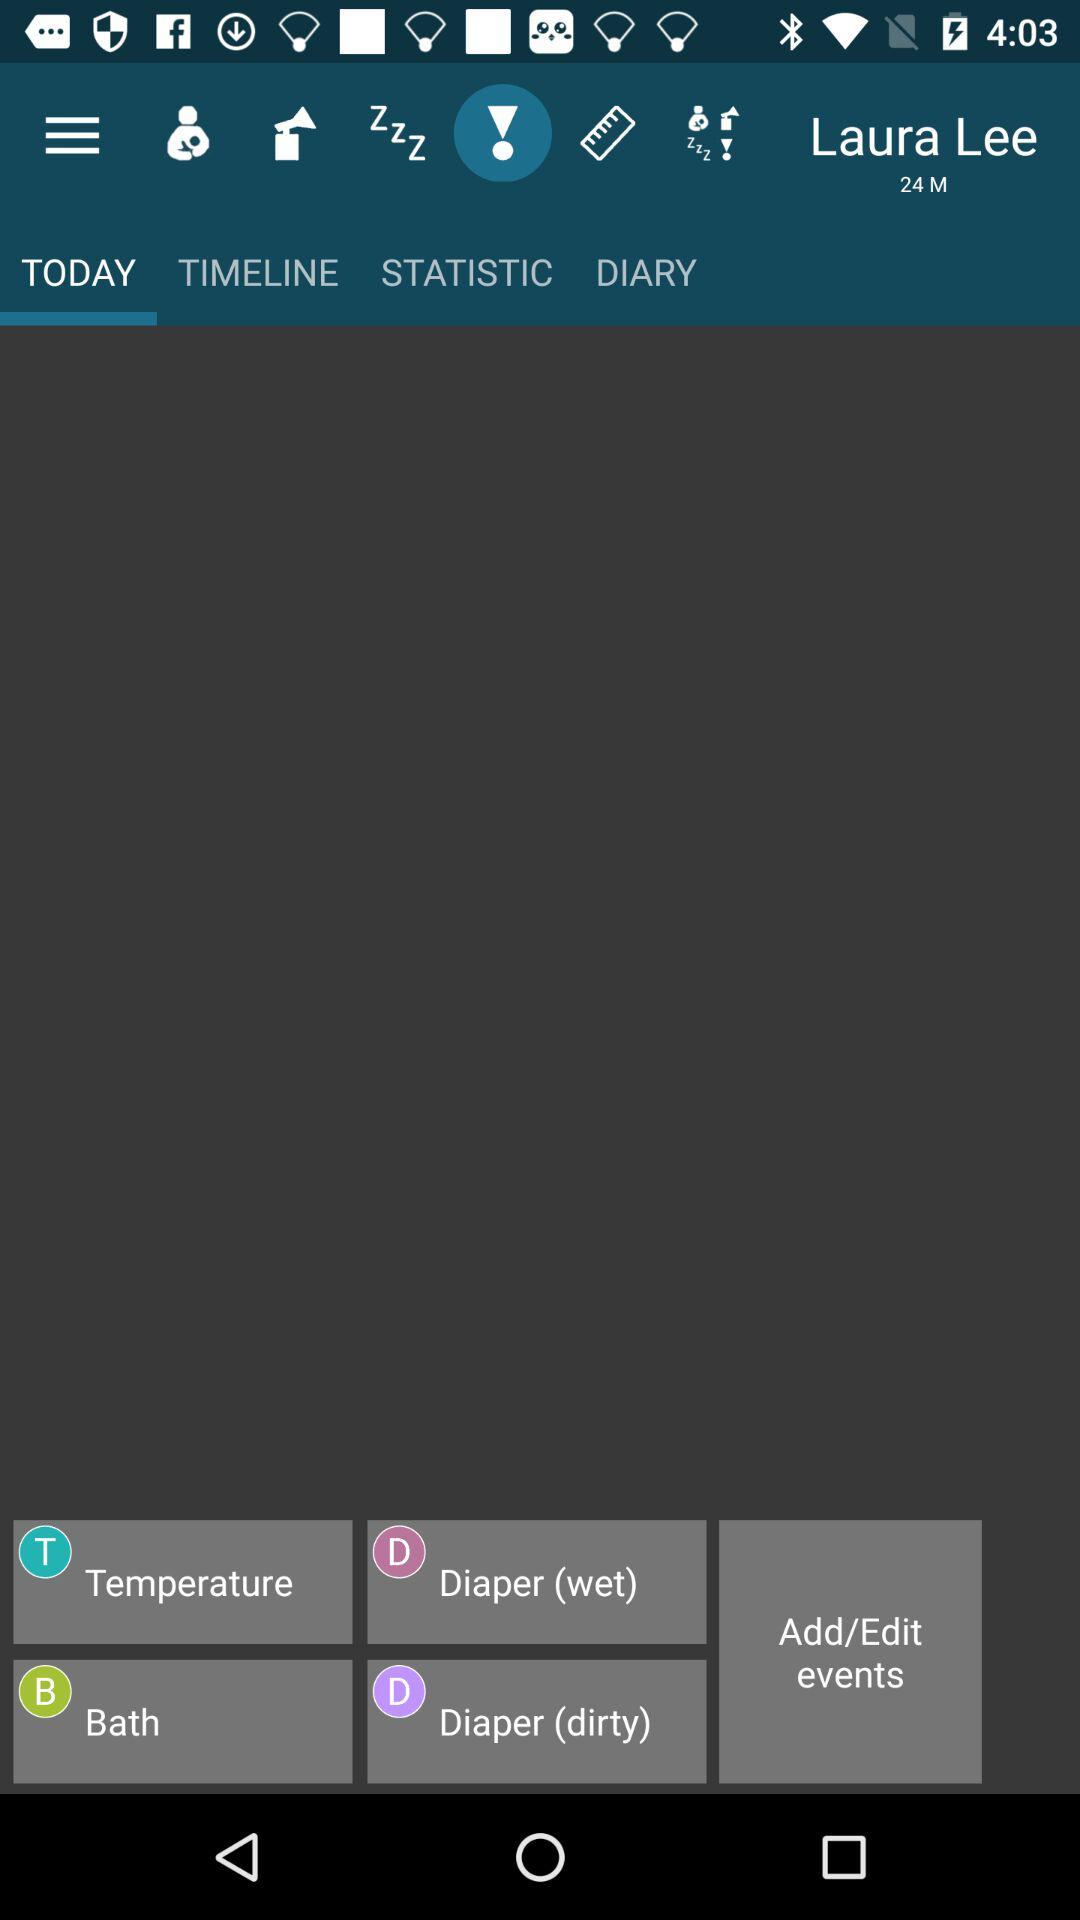What is the user name shown on the screen? The user name is Laura Lee. 